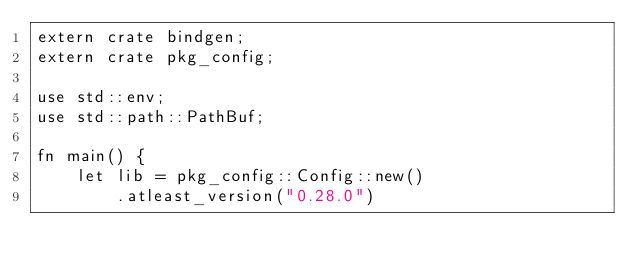<code> <loc_0><loc_0><loc_500><loc_500><_Rust_>extern crate bindgen;
extern crate pkg_config;

use std::env;
use std::path::PathBuf;

fn main() {
    let lib = pkg_config::Config::new()
        .atleast_version("0.28.0")</code> 